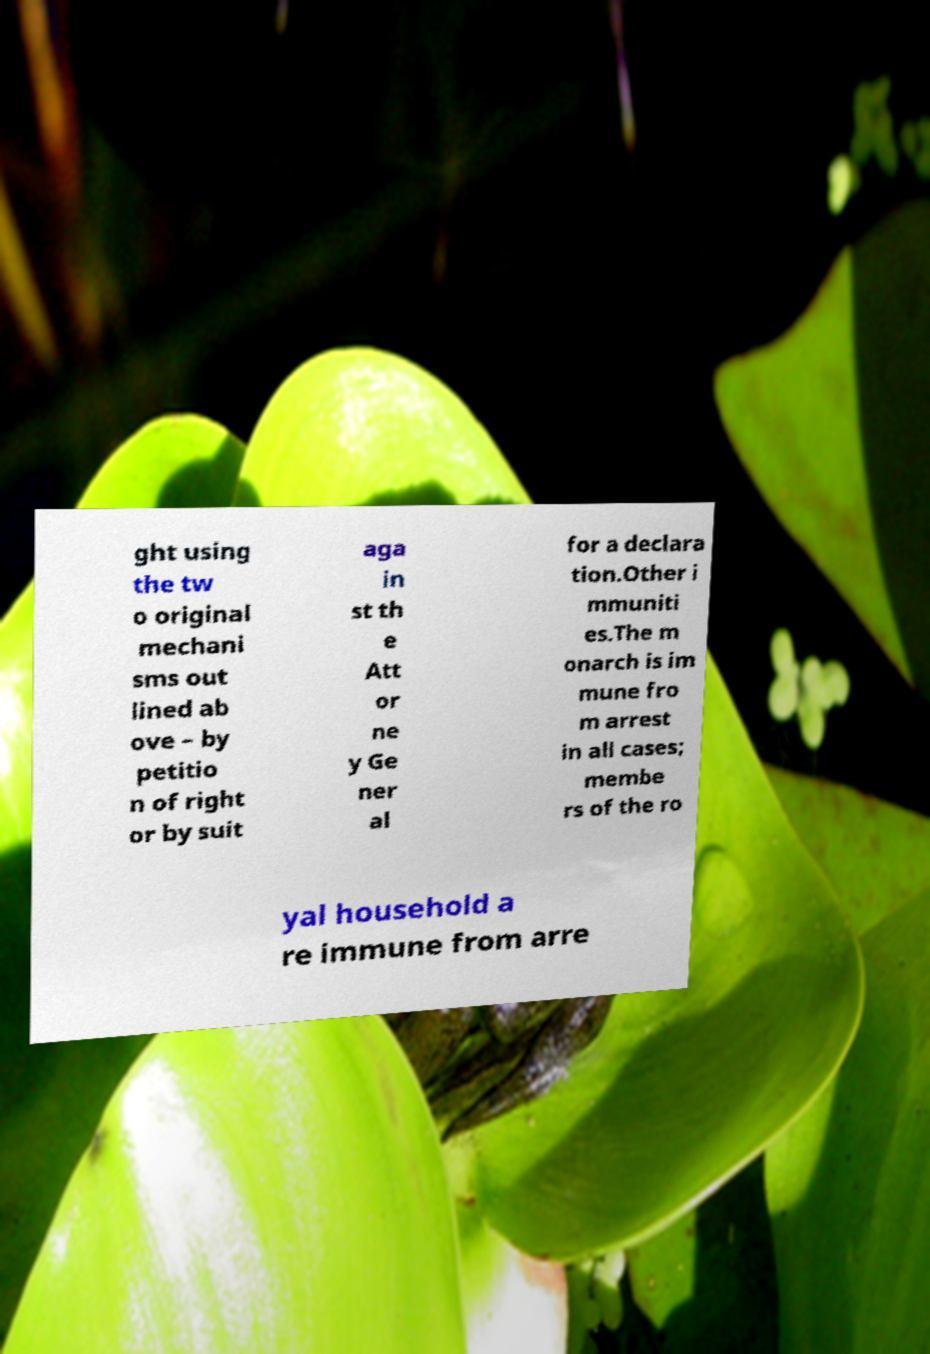For documentation purposes, I need the text within this image transcribed. Could you provide that? ght using the tw o original mechani sms out lined ab ove – by petitio n of right or by suit aga in st th e Att or ne y Ge ner al for a declara tion.Other i mmuniti es.The m onarch is im mune fro m arrest in all cases; membe rs of the ro yal household a re immune from arre 